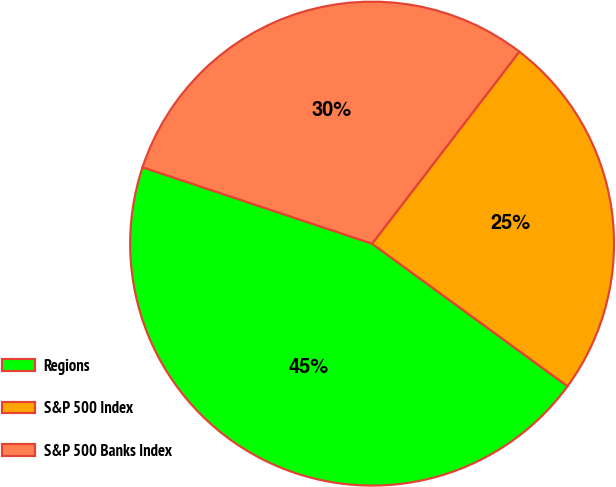<chart> <loc_0><loc_0><loc_500><loc_500><pie_chart><fcel>Regions<fcel>S&P 500 Index<fcel>S&P 500 Banks Index<nl><fcel>45.09%<fcel>24.62%<fcel>30.3%<nl></chart> 